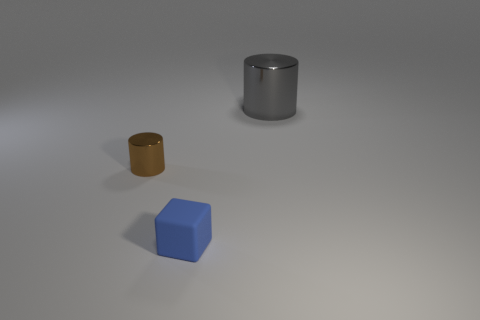Is there any other thing that has the same material as the small blue object?
Your response must be concise. No. How many large things are either brown metal blocks or blue objects?
Ensure brevity in your answer.  0. There is a gray thing that is made of the same material as the brown cylinder; what shape is it?
Provide a succinct answer. Cylinder. Is the matte thing the same shape as the small shiny object?
Your answer should be very brief. No. The big thing has what color?
Your answer should be very brief. Gray. How many things are small brown shiny things or large shiny cylinders?
Your response must be concise. 2. Are there fewer cylinders in front of the rubber cube than tiny cubes?
Your answer should be compact. Yes. Is the number of tiny brown metal objects in front of the small brown metallic cylinder greater than the number of tiny blue cubes that are left of the gray metal object?
Your answer should be compact. No. Are there any other things that have the same color as the rubber object?
Your answer should be very brief. No. There is a object that is to the right of the blue object; what is it made of?
Your answer should be very brief. Metal. 